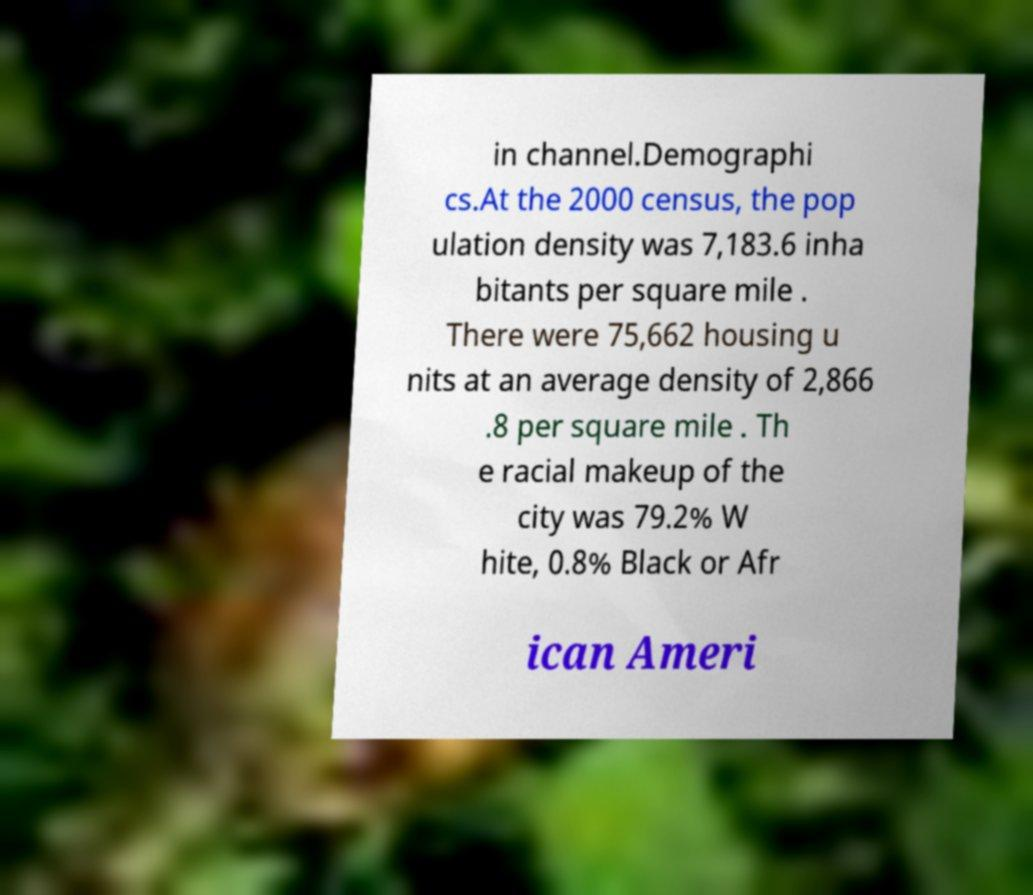Could you extract and type out the text from this image? in channel.Demographi cs.At the 2000 census, the pop ulation density was 7,183.6 inha bitants per square mile . There were 75,662 housing u nits at an average density of 2,866 .8 per square mile . Th e racial makeup of the city was 79.2% W hite, 0.8% Black or Afr ican Ameri 